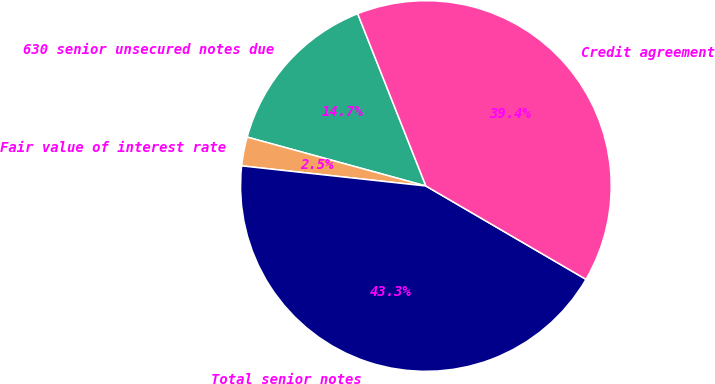Convert chart. <chart><loc_0><loc_0><loc_500><loc_500><pie_chart><fcel>630 senior unsecured notes due<fcel>Fair value of interest rate<fcel>Total senior notes<fcel>Credit agreement<nl><fcel>14.75%<fcel>2.52%<fcel>43.33%<fcel>39.4%<nl></chart> 